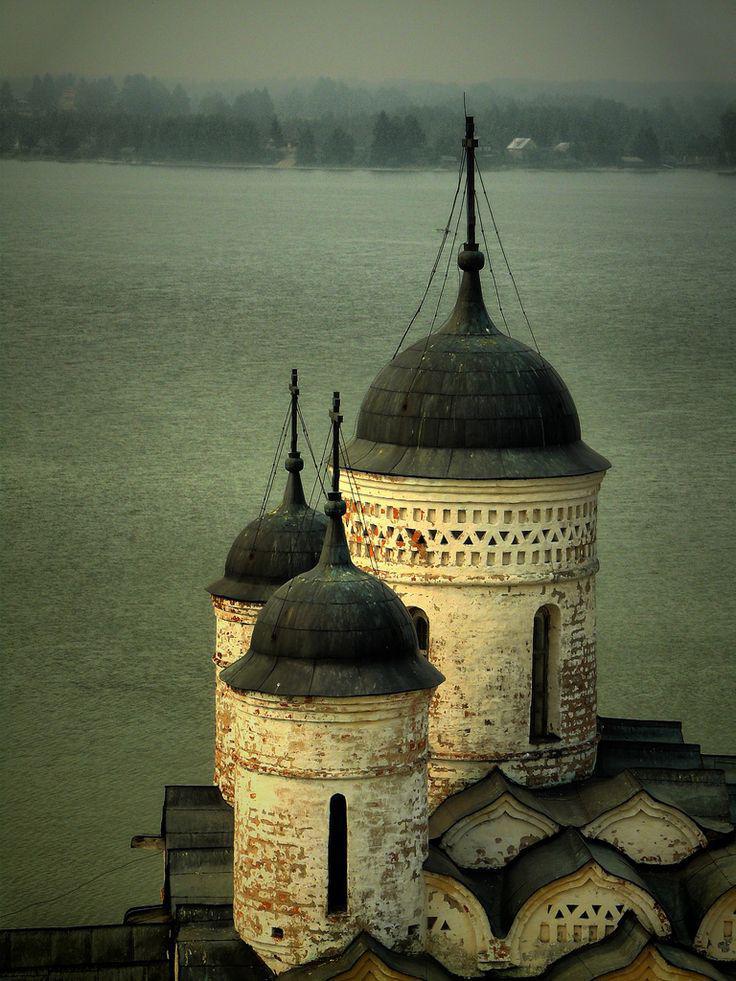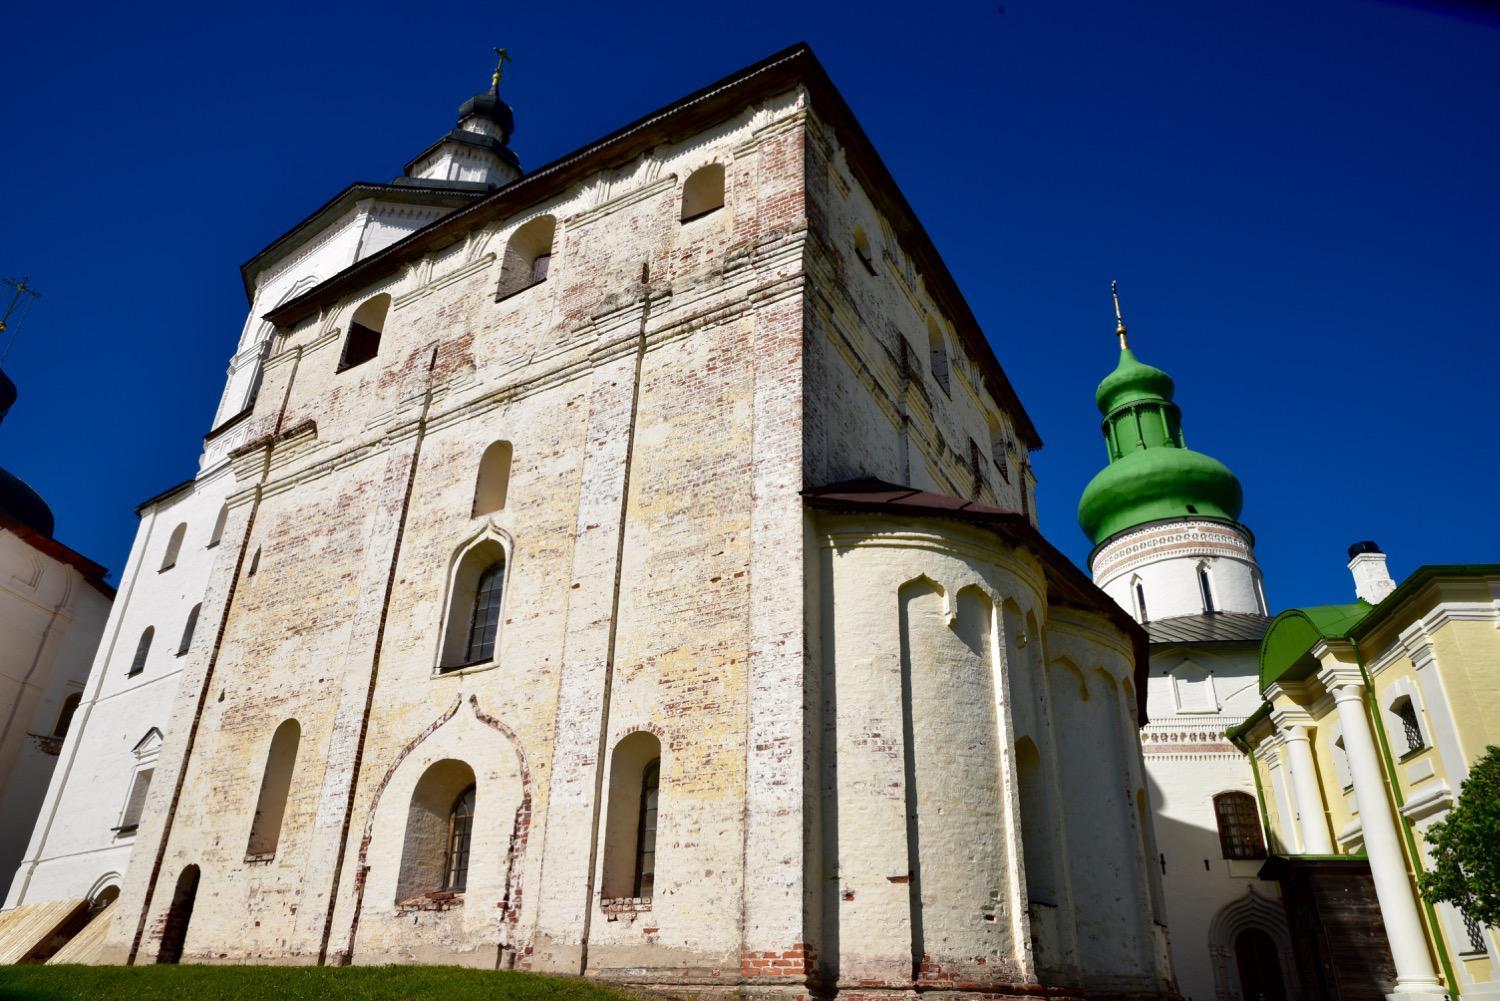The first image is the image on the left, the second image is the image on the right. Considering the images on both sides, is "There are two steeples in the image on the right." valid? Answer yes or no. Yes. The first image is the image on the left, the second image is the image on the right. For the images displayed, is the sentence "An image shows a building with a tall black-topped tower on top of a black peaked roof, in front of a vivid blue with only a tiny cloud patch visible." factually correct? Answer yes or no. No. 